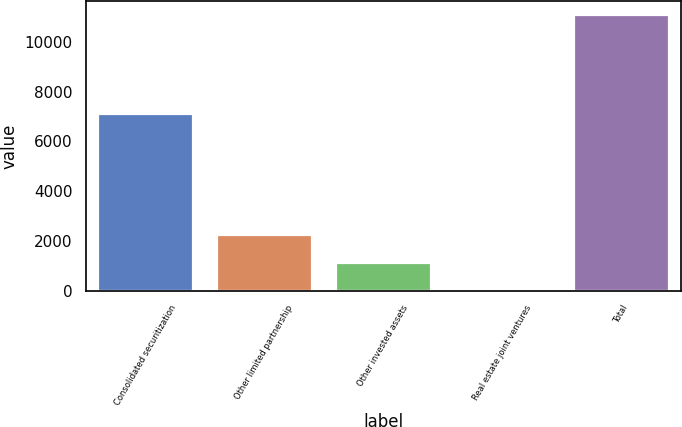Convert chart to OTSL. <chart><loc_0><loc_0><loc_500><loc_500><bar_chart><fcel>Consolidated securitization<fcel>Other limited partnership<fcel>Other invested assets<fcel>Real estate joint ventures<fcel>Total<nl><fcel>7114<fcel>2232<fcel>1126<fcel>20<fcel>11080<nl></chart> 